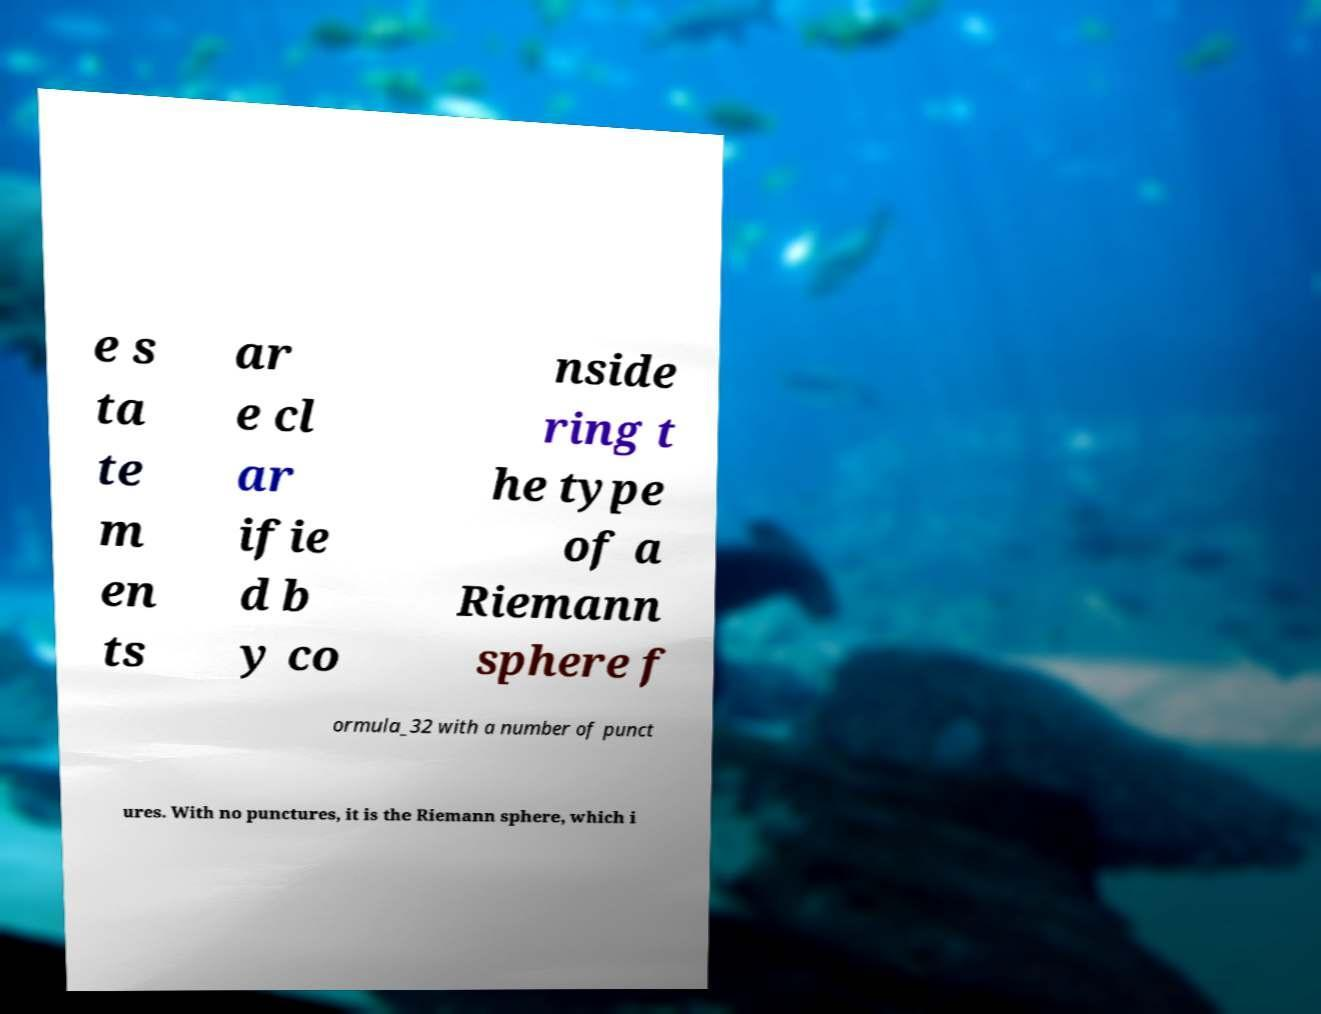I need the written content from this picture converted into text. Can you do that? e s ta te m en ts ar e cl ar ifie d b y co nside ring t he type of a Riemann sphere f ormula_32 with a number of punct ures. With no punctures, it is the Riemann sphere, which i 